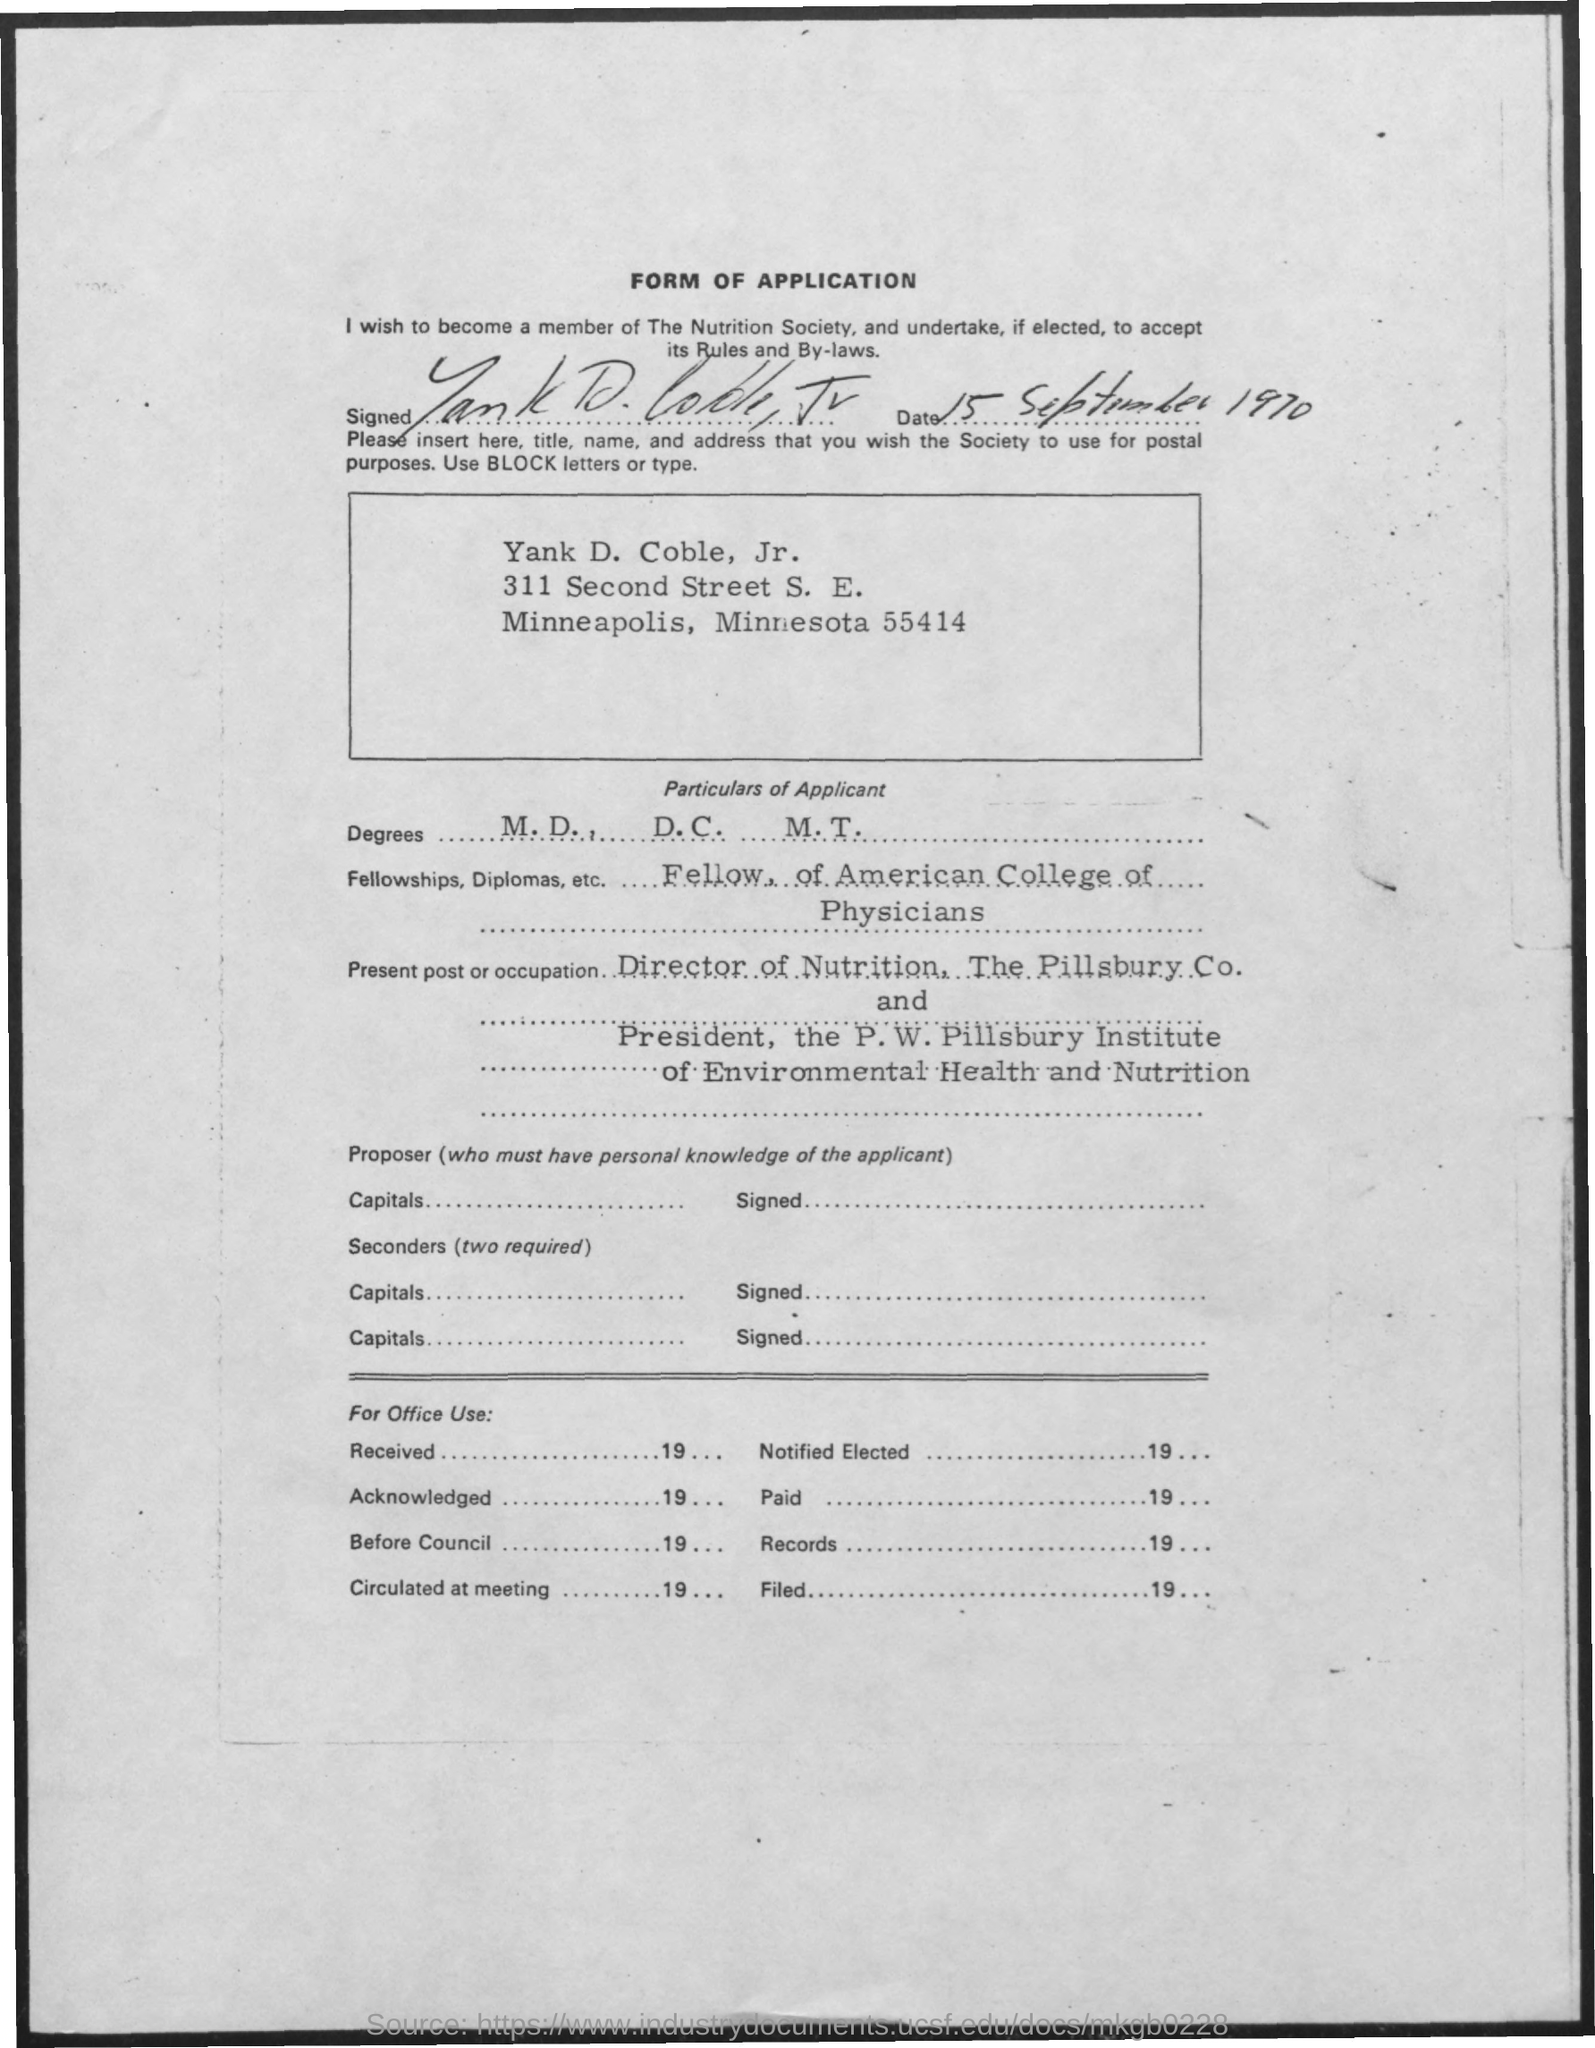Specify some key components in this picture. The date mentioned is September 15, 1970. The fellowships, diplomas, and other qualifications mentioned in the American College of Physicians form are: [insert list of qualifications here]. The degrees mentioned are M.D., D.C., and M.T. 